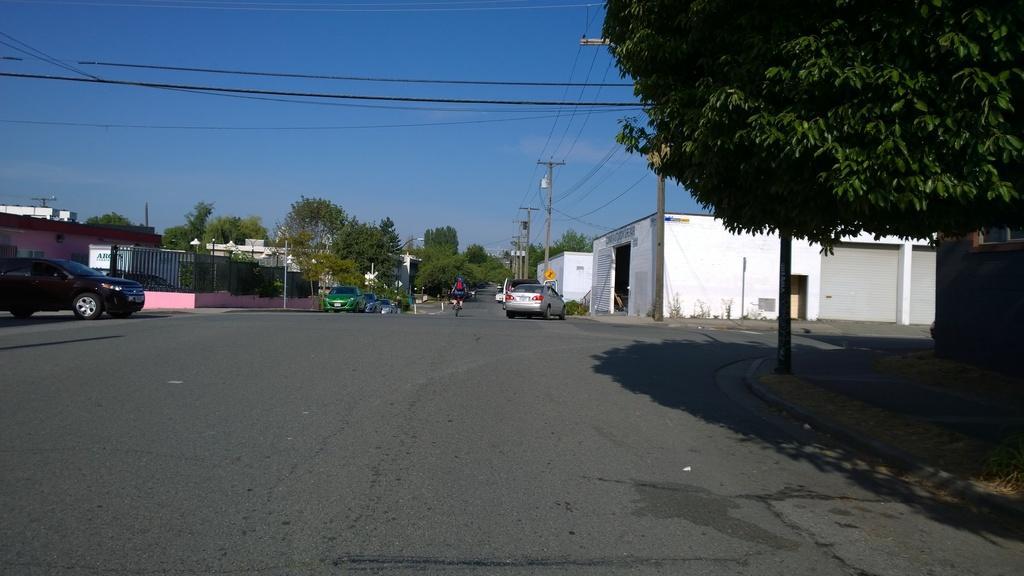Could you give a brief overview of what you see in this image? In this image on the right side and left side there are some trees, houses, buildings, poles and wires. And at the bottom there is a road, on the road there are some cars and one cycle and one person is sitting on a cycle. On the top of the image there are some wires. 